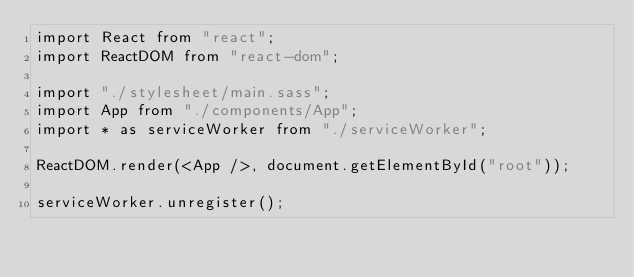<code> <loc_0><loc_0><loc_500><loc_500><_JavaScript_>import React from "react";
import ReactDOM from "react-dom";

import "./stylesheet/main.sass";
import App from "./components/App";
import * as serviceWorker from "./serviceWorker";

ReactDOM.render(<App />, document.getElementById("root"));

serviceWorker.unregister();
</code> 